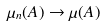Convert formula to latex. <formula><loc_0><loc_0><loc_500><loc_500>\mu _ { n } ( A ) \rightarrow \mu ( A )</formula> 